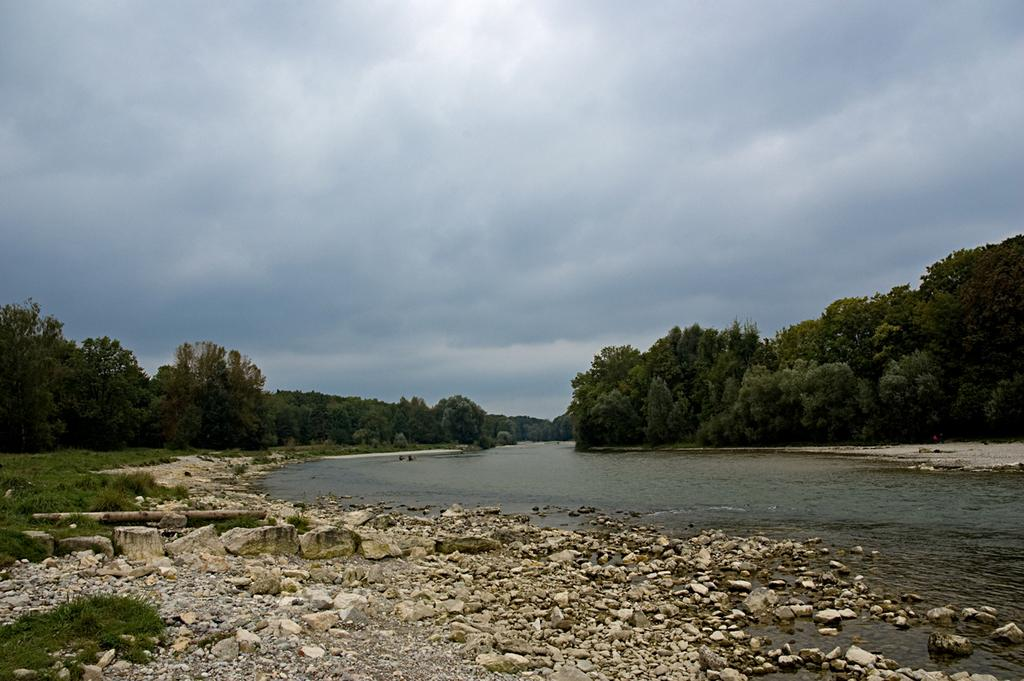What type of vegetation can be seen in the image? There are trees in the image. What other natural elements are present in the image? There are stones and rocks, as well as water visible in the image. How would you describe the sky in the image? The sky is cloudy in the image. What type of ground cover is present in the image? There is grass on the ground in the image. What is the income of the trees in the image? Trees do not have an income, as they are living organisms and not capable of earning money. Is there a balloon visible in the image? There is no mention of a balloon in the provided facts, so it cannot be determined if one is present in the image. 